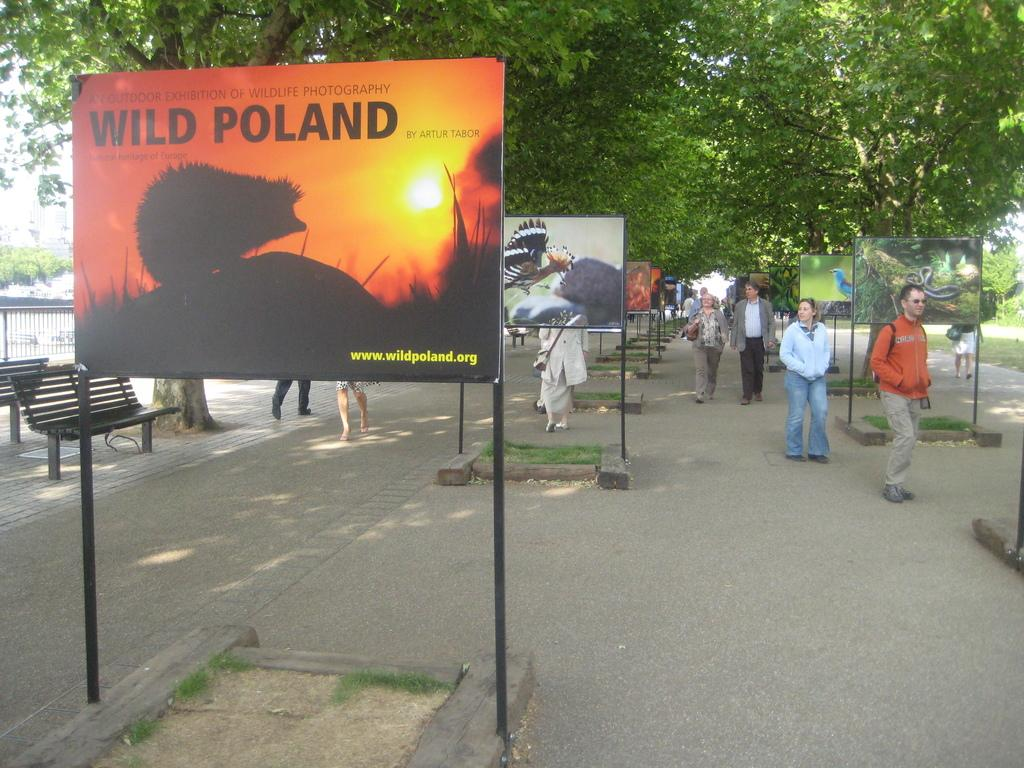<image>
Create a compact narrative representing the image presented. Different signs and a name that says Wild Poland on it. 